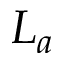<formula> <loc_0><loc_0><loc_500><loc_500>L _ { a }</formula> 